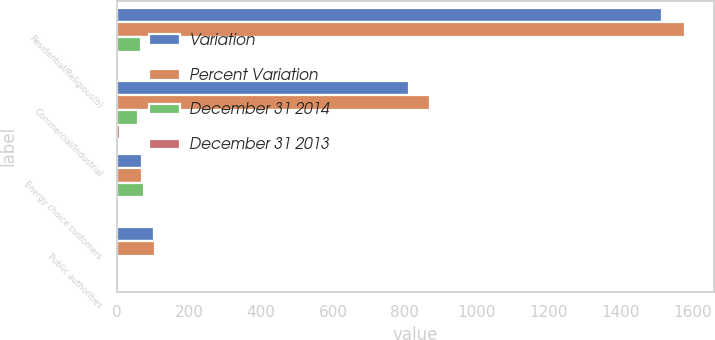Convert chart to OTSL. <chart><loc_0><loc_0><loc_500><loc_500><stacked_bar_chart><ecel><fcel>Residential/Religious(b)<fcel>Commercial/Industrial<fcel>Energy choice customers<fcel>Public authorities<nl><fcel>Variation<fcel>1515<fcel>812<fcel>69.5<fcel>102<nl><fcel>Percent Variation<fcel>1580<fcel>871<fcel>69.5<fcel>104<nl><fcel>December 31 2014<fcel>65<fcel>59<fcel>74<fcel>2<nl><fcel>December 31 2013<fcel>4.1<fcel>6.8<fcel>2.3<fcel>1.9<nl></chart> 